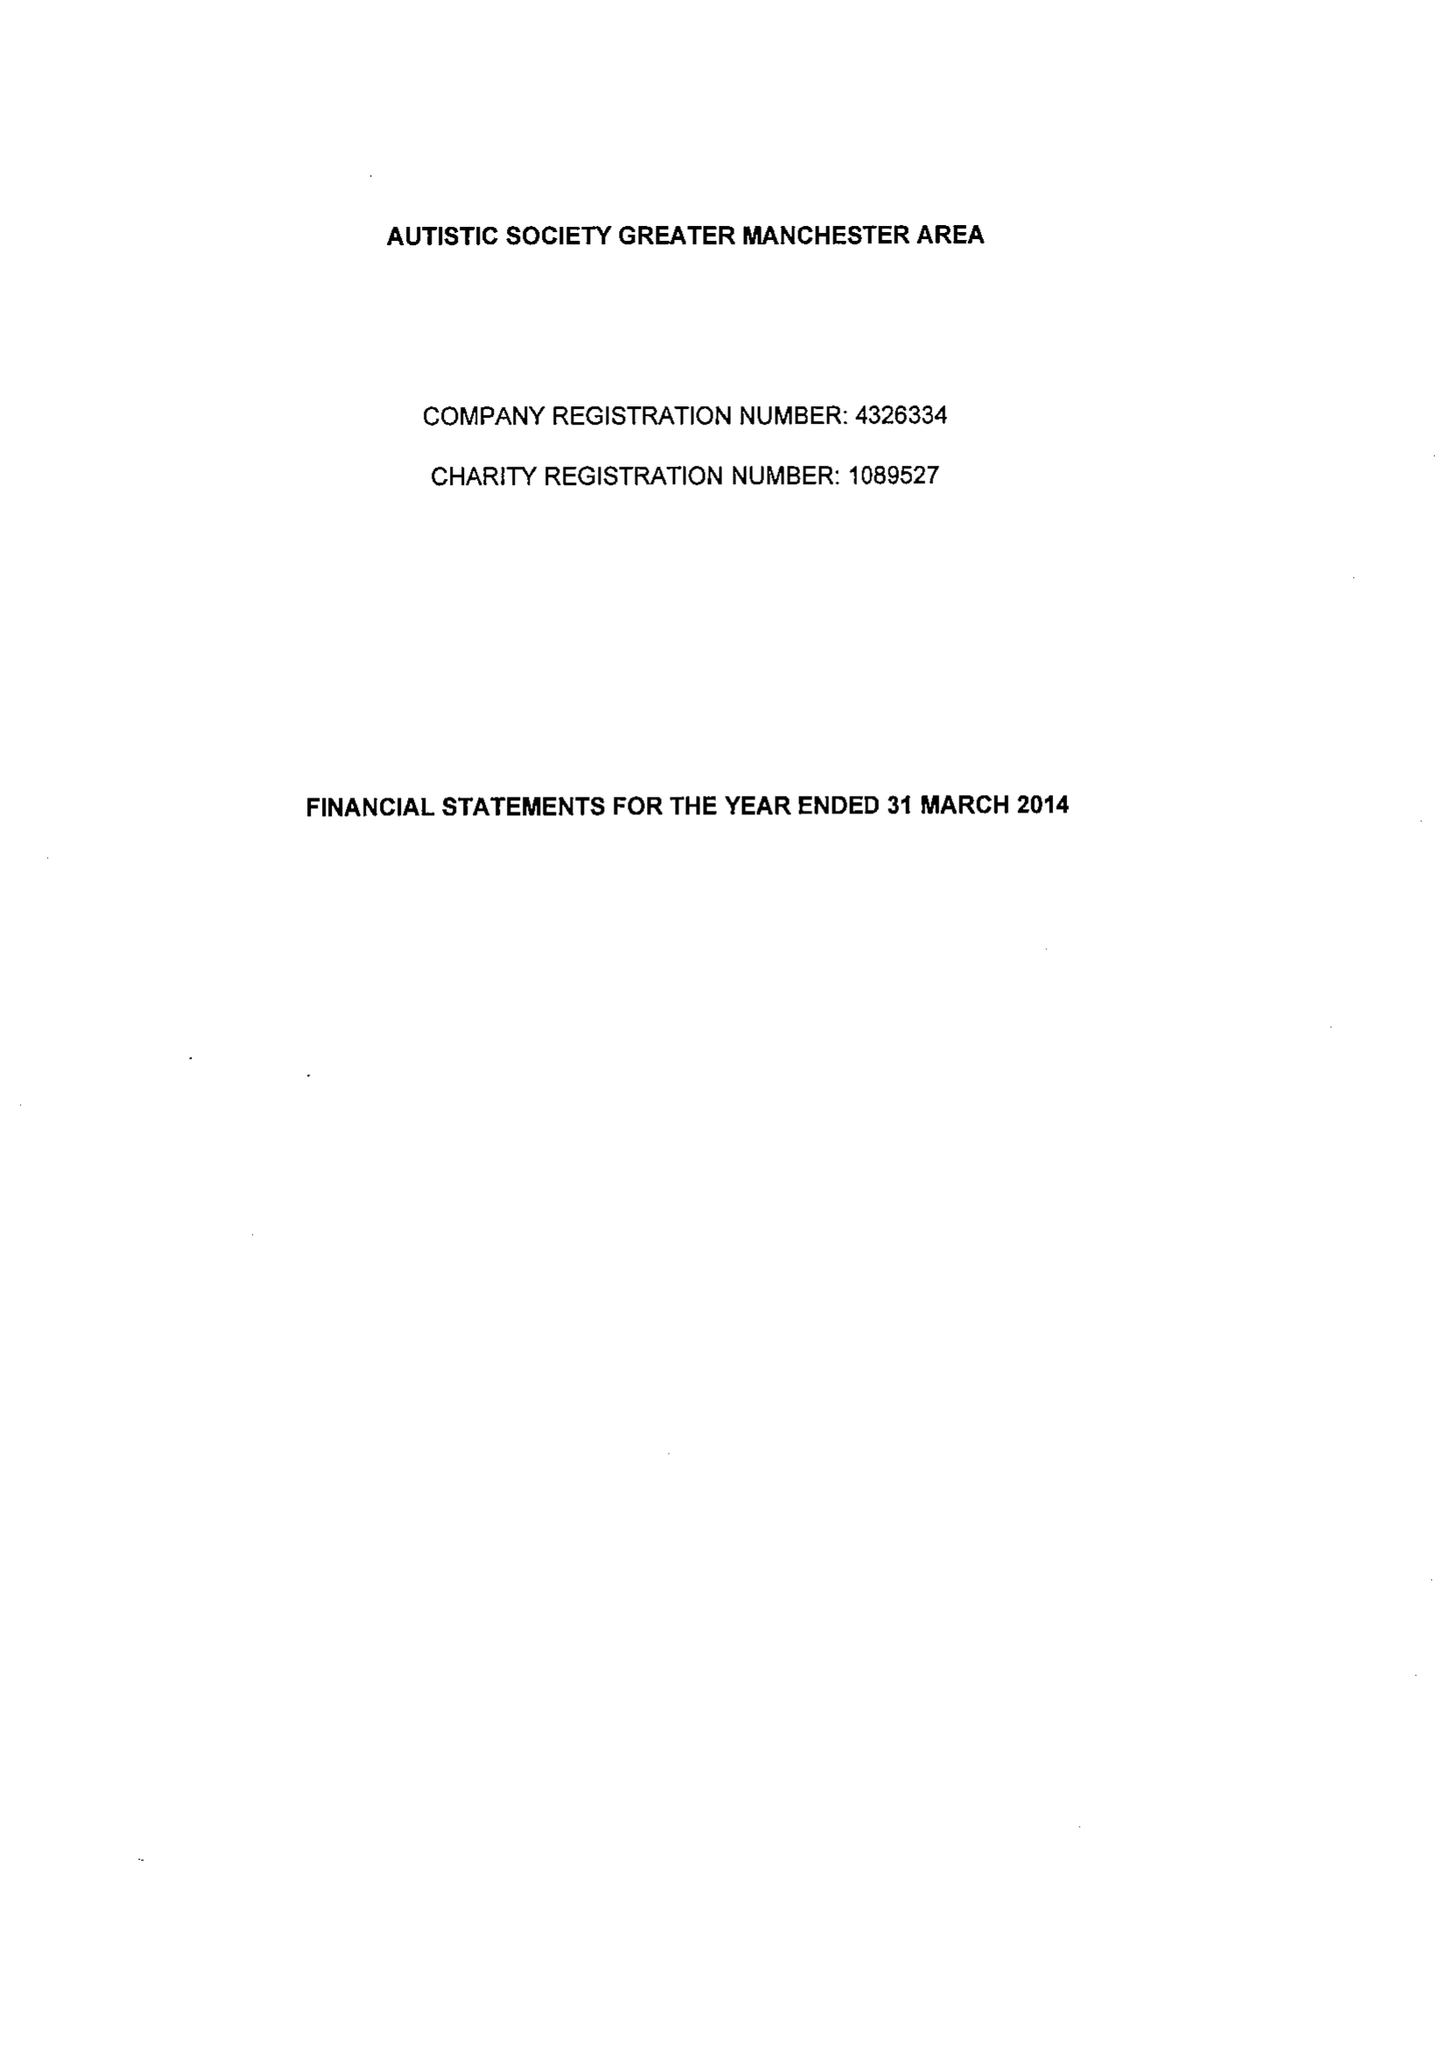What is the value for the report_date?
Answer the question using a single word or phrase. 2014-03-31 